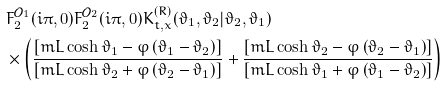Convert formula to latex. <formula><loc_0><loc_0><loc_500><loc_500>& F _ { 2 } ^ { \mathcal { O } _ { 1 } } ( i \pi , 0 ) F _ { 2 } ^ { \mathcal { O } _ { 2 } } ( i \pi , 0 ) K _ { t , x } ^ { \left ( R \right ) } ( \vartheta _ { 1 } , \vartheta _ { 2 } | \vartheta _ { 2 } , \vartheta _ { 1 } ) \\ & \times \left ( \frac { \left [ m L \cosh \vartheta _ { 1 } - \varphi \left ( \vartheta _ { 1 } - \vartheta _ { 2 } \right ) \right ] } { \left [ m L \cosh \vartheta _ { 2 } + \varphi \left ( \vartheta _ { 2 } - \vartheta _ { 1 } \right ) \right ] } + \frac { \left [ m L \cosh \vartheta _ { 2 } - \varphi \left ( \vartheta _ { 2 } - \vartheta _ { 1 } \right ) \right ] } { \left [ m L \cosh \vartheta _ { 1 } + \varphi \left ( \vartheta _ { 1 } - \vartheta _ { 2 } \right ) \right ] } \right )</formula> 